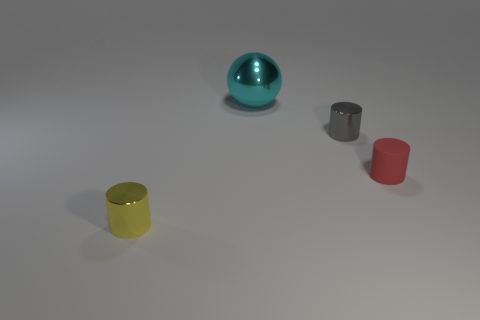Add 1 purple shiny spheres. How many objects exist? 5 Subtract all balls. How many objects are left? 3 Add 1 small red rubber cylinders. How many small red rubber cylinders are left? 2 Add 1 cyan spheres. How many cyan spheres exist? 2 Subtract 0 brown cylinders. How many objects are left? 4 Subtract all yellow shiny cylinders. Subtract all small gray things. How many objects are left? 2 